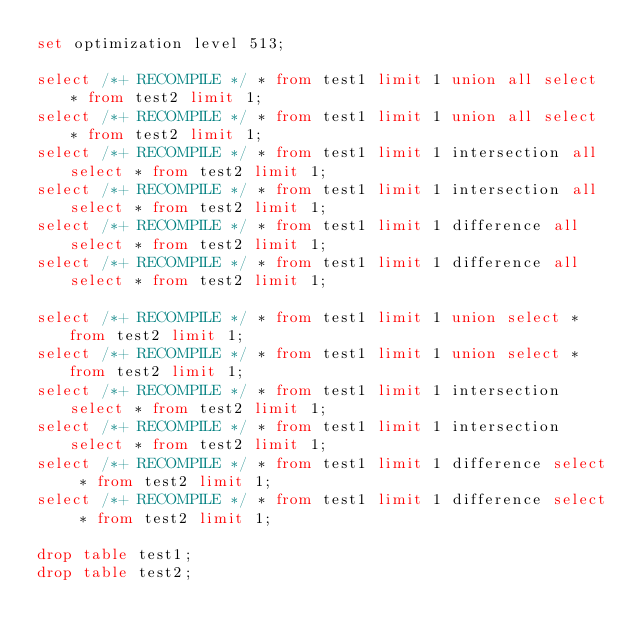Convert code to text. <code><loc_0><loc_0><loc_500><loc_500><_SQL_>set optimization level 513;

select /*+ RECOMPILE */ * from test1 limit 1 union all select * from test2 limit 1;
select /*+ RECOMPILE */ * from test1 limit 1 union all select * from test2 limit 1;
select /*+ RECOMPILE */ * from test1 limit 1 intersection all select * from test2 limit 1;
select /*+ RECOMPILE */ * from test1 limit 1 intersection all select * from test2 limit 1;
select /*+ RECOMPILE */ * from test1 limit 1 difference all select * from test2 limit 1;
select /*+ RECOMPILE */ * from test1 limit 1 difference all select * from test2 limit 1;

select /*+ RECOMPILE */ * from test1 limit 1 union select * from test2 limit 1;
select /*+ RECOMPILE */ * from test1 limit 1 union select * from test2 limit 1;
select /*+ RECOMPILE */ * from test1 limit 1 intersection select * from test2 limit 1;
select /*+ RECOMPILE */ * from test1 limit 1 intersection select * from test2 limit 1;
select /*+ RECOMPILE */ * from test1 limit 1 difference select * from test2 limit 1;
select /*+ RECOMPILE */ * from test1 limit 1 difference select * from test2 limit 1;

drop table test1;
drop table test2;
</code> 